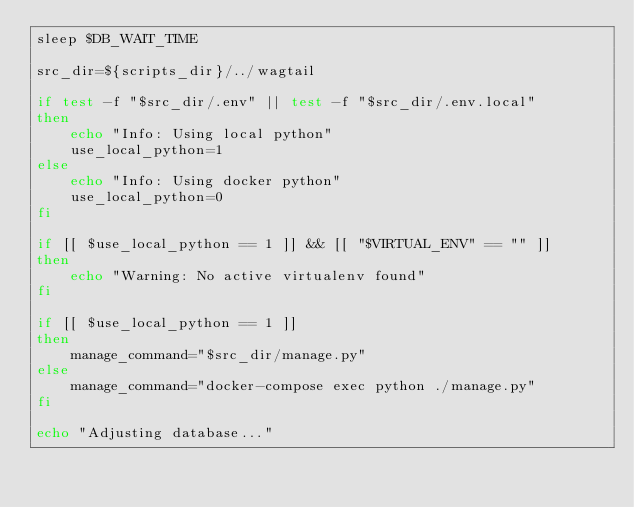Convert code to text. <code><loc_0><loc_0><loc_500><loc_500><_Bash_>sleep $DB_WAIT_TIME

src_dir=${scripts_dir}/../wagtail

if test -f "$src_dir/.env" || test -f "$src_dir/.env.local"
then
    echo "Info: Using local python"
    use_local_python=1
else
    echo "Info: Using docker python"
    use_local_python=0
fi

if [[ $use_local_python == 1 ]] && [[ "$VIRTUAL_ENV" == "" ]]
then
    echo "Warning: No active virtualenv found"
fi

if [[ $use_local_python == 1 ]]
then
    manage_command="$src_dir/manage.py"
else
    manage_command="docker-compose exec python ./manage.py"
fi

echo "Adjusting database..."</code> 